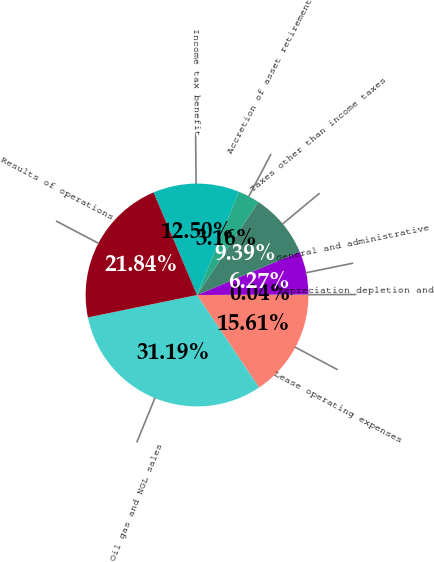<chart> <loc_0><loc_0><loc_500><loc_500><pie_chart><fcel>Oil gas and NGL sales<fcel>Lease operating expenses<fcel>Depreciation depletion and<fcel>General and administrative<fcel>Taxes other than income taxes<fcel>Accretion of asset retirement<fcel>Income tax benefit<fcel>Results of operations<nl><fcel>31.19%<fcel>15.61%<fcel>0.04%<fcel>6.27%<fcel>9.39%<fcel>3.16%<fcel>12.5%<fcel>21.84%<nl></chart> 